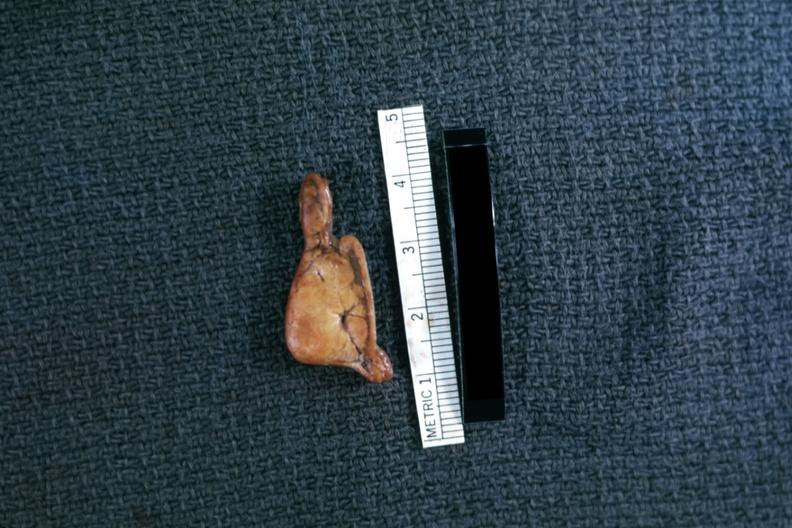s hemorrhage newborn present?
Answer the question using a single word or phrase. No 